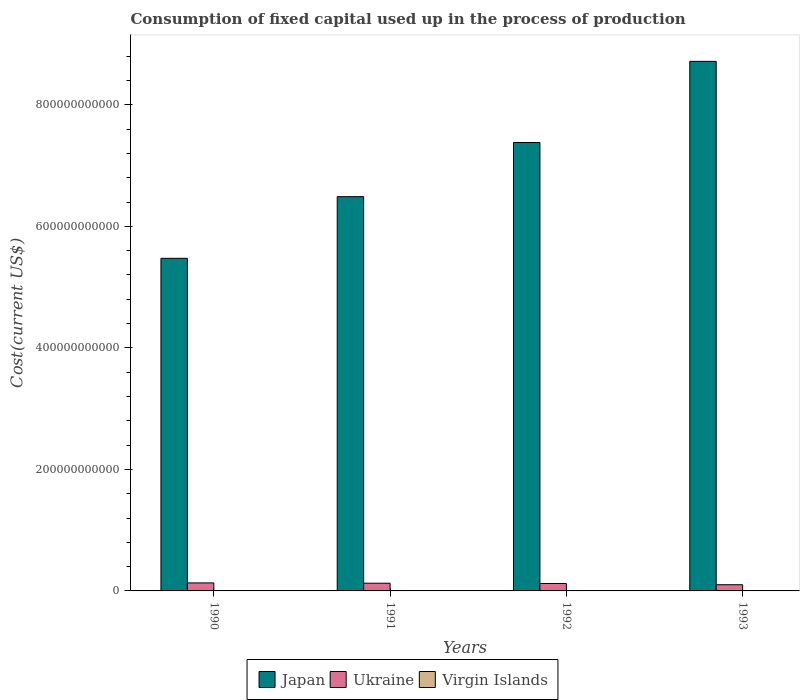How many different coloured bars are there?
Provide a succinct answer. 3. How many groups of bars are there?
Give a very brief answer. 4. Are the number of bars per tick equal to the number of legend labels?
Make the answer very short. Yes. How many bars are there on the 1st tick from the left?
Give a very brief answer. 3. What is the amount consumed in the process of production in Japan in 1992?
Provide a succinct answer. 7.38e+11. Across all years, what is the maximum amount consumed in the process of production in Japan?
Provide a succinct answer. 8.72e+11. Across all years, what is the minimum amount consumed in the process of production in Virgin Islands?
Make the answer very short. 2.21e+08. In which year was the amount consumed in the process of production in Virgin Islands maximum?
Your response must be concise. 1993. What is the total amount consumed in the process of production in Japan in the graph?
Make the answer very short. 2.81e+12. What is the difference between the amount consumed in the process of production in Ukraine in 1992 and that in 1993?
Your answer should be very brief. 2.01e+09. What is the difference between the amount consumed in the process of production in Ukraine in 1991 and the amount consumed in the process of production in Virgin Islands in 1990?
Give a very brief answer. 1.24e+1. What is the average amount consumed in the process of production in Ukraine per year?
Offer a very short reply. 1.21e+1. In the year 1991, what is the difference between the amount consumed in the process of production in Japan and amount consumed in the process of production in Ukraine?
Give a very brief answer. 6.36e+11. What is the ratio of the amount consumed in the process of production in Ukraine in 1990 to that in 1993?
Provide a short and direct response. 1.29. Is the amount consumed in the process of production in Ukraine in 1992 less than that in 1993?
Make the answer very short. No. What is the difference between the highest and the second highest amount consumed in the process of production in Virgin Islands?
Your answer should be very brief. 3.59e+07. What is the difference between the highest and the lowest amount consumed in the process of production in Ukraine?
Your answer should be compact. 2.97e+09. In how many years, is the amount consumed in the process of production in Japan greater than the average amount consumed in the process of production in Japan taken over all years?
Give a very brief answer. 2. Is the sum of the amount consumed in the process of production in Virgin Islands in 1990 and 1992 greater than the maximum amount consumed in the process of production in Ukraine across all years?
Make the answer very short. No. What does the 3rd bar from the left in 1992 represents?
Keep it short and to the point. Virgin Islands. What does the 2nd bar from the right in 1992 represents?
Keep it short and to the point. Ukraine. Are all the bars in the graph horizontal?
Your answer should be compact. No. How many years are there in the graph?
Make the answer very short. 4. What is the difference between two consecutive major ticks on the Y-axis?
Offer a very short reply. 2.00e+11. Are the values on the major ticks of Y-axis written in scientific E-notation?
Your answer should be compact. No. Where does the legend appear in the graph?
Provide a short and direct response. Bottom center. How many legend labels are there?
Your response must be concise. 3. How are the legend labels stacked?
Ensure brevity in your answer.  Horizontal. What is the title of the graph?
Your answer should be very brief. Consumption of fixed capital used up in the process of production. Does "Moldova" appear as one of the legend labels in the graph?
Provide a short and direct response. No. What is the label or title of the X-axis?
Ensure brevity in your answer.  Years. What is the label or title of the Y-axis?
Your answer should be compact. Cost(current US$). What is the Cost(current US$) of Japan in 1990?
Offer a terse response. 5.47e+11. What is the Cost(current US$) in Ukraine in 1990?
Make the answer very short. 1.32e+1. What is the Cost(current US$) of Virgin Islands in 1990?
Give a very brief answer. 2.21e+08. What is the Cost(current US$) in Japan in 1991?
Your answer should be compact. 6.49e+11. What is the Cost(current US$) of Ukraine in 1991?
Provide a short and direct response. 1.27e+1. What is the Cost(current US$) in Virgin Islands in 1991?
Offer a very short reply. 2.37e+08. What is the Cost(current US$) of Japan in 1992?
Provide a succinct answer. 7.38e+11. What is the Cost(current US$) of Ukraine in 1992?
Ensure brevity in your answer.  1.22e+1. What is the Cost(current US$) of Virgin Islands in 1992?
Your answer should be very brief. 2.53e+08. What is the Cost(current US$) in Japan in 1993?
Ensure brevity in your answer.  8.72e+11. What is the Cost(current US$) in Ukraine in 1993?
Offer a very short reply. 1.02e+1. What is the Cost(current US$) of Virgin Islands in 1993?
Your answer should be compact. 2.89e+08. Across all years, what is the maximum Cost(current US$) of Japan?
Your answer should be very brief. 8.72e+11. Across all years, what is the maximum Cost(current US$) of Ukraine?
Give a very brief answer. 1.32e+1. Across all years, what is the maximum Cost(current US$) in Virgin Islands?
Give a very brief answer. 2.89e+08. Across all years, what is the minimum Cost(current US$) of Japan?
Ensure brevity in your answer.  5.47e+11. Across all years, what is the minimum Cost(current US$) of Ukraine?
Offer a terse response. 1.02e+1. Across all years, what is the minimum Cost(current US$) of Virgin Islands?
Provide a succinct answer. 2.21e+08. What is the total Cost(current US$) in Japan in the graph?
Ensure brevity in your answer.  2.81e+12. What is the total Cost(current US$) in Ukraine in the graph?
Your response must be concise. 4.82e+1. What is the total Cost(current US$) of Virgin Islands in the graph?
Keep it short and to the point. 1.00e+09. What is the difference between the Cost(current US$) in Japan in 1990 and that in 1991?
Provide a succinct answer. -1.01e+11. What is the difference between the Cost(current US$) in Ukraine in 1990 and that in 1991?
Offer a terse response. 5.13e+08. What is the difference between the Cost(current US$) in Virgin Islands in 1990 and that in 1991?
Your answer should be compact. -1.67e+07. What is the difference between the Cost(current US$) of Japan in 1990 and that in 1992?
Give a very brief answer. -1.91e+11. What is the difference between the Cost(current US$) of Ukraine in 1990 and that in 1992?
Your response must be concise. 9.63e+08. What is the difference between the Cost(current US$) in Virgin Islands in 1990 and that in 1992?
Your answer should be compact. -3.25e+07. What is the difference between the Cost(current US$) in Japan in 1990 and that in 1993?
Your answer should be compact. -3.24e+11. What is the difference between the Cost(current US$) of Ukraine in 1990 and that in 1993?
Offer a very short reply. 2.97e+09. What is the difference between the Cost(current US$) in Virgin Islands in 1990 and that in 1993?
Make the answer very short. -6.84e+07. What is the difference between the Cost(current US$) of Japan in 1991 and that in 1992?
Your response must be concise. -8.91e+1. What is the difference between the Cost(current US$) of Ukraine in 1991 and that in 1992?
Your answer should be very brief. 4.50e+08. What is the difference between the Cost(current US$) in Virgin Islands in 1991 and that in 1992?
Ensure brevity in your answer.  -1.58e+07. What is the difference between the Cost(current US$) of Japan in 1991 and that in 1993?
Provide a short and direct response. -2.23e+11. What is the difference between the Cost(current US$) in Ukraine in 1991 and that in 1993?
Your answer should be compact. 2.46e+09. What is the difference between the Cost(current US$) of Virgin Islands in 1991 and that in 1993?
Offer a very short reply. -5.16e+07. What is the difference between the Cost(current US$) in Japan in 1992 and that in 1993?
Your answer should be very brief. -1.34e+11. What is the difference between the Cost(current US$) in Ukraine in 1992 and that in 1993?
Make the answer very short. 2.01e+09. What is the difference between the Cost(current US$) of Virgin Islands in 1992 and that in 1993?
Offer a very short reply. -3.59e+07. What is the difference between the Cost(current US$) in Japan in 1990 and the Cost(current US$) in Ukraine in 1991?
Offer a terse response. 5.35e+11. What is the difference between the Cost(current US$) in Japan in 1990 and the Cost(current US$) in Virgin Islands in 1991?
Your response must be concise. 5.47e+11. What is the difference between the Cost(current US$) of Ukraine in 1990 and the Cost(current US$) of Virgin Islands in 1991?
Keep it short and to the point. 1.29e+1. What is the difference between the Cost(current US$) of Japan in 1990 and the Cost(current US$) of Ukraine in 1992?
Offer a very short reply. 5.35e+11. What is the difference between the Cost(current US$) in Japan in 1990 and the Cost(current US$) in Virgin Islands in 1992?
Offer a terse response. 5.47e+11. What is the difference between the Cost(current US$) in Ukraine in 1990 and the Cost(current US$) in Virgin Islands in 1992?
Offer a very short reply. 1.29e+1. What is the difference between the Cost(current US$) of Japan in 1990 and the Cost(current US$) of Ukraine in 1993?
Your answer should be very brief. 5.37e+11. What is the difference between the Cost(current US$) of Japan in 1990 and the Cost(current US$) of Virgin Islands in 1993?
Ensure brevity in your answer.  5.47e+11. What is the difference between the Cost(current US$) of Ukraine in 1990 and the Cost(current US$) of Virgin Islands in 1993?
Offer a terse response. 1.29e+1. What is the difference between the Cost(current US$) in Japan in 1991 and the Cost(current US$) in Ukraine in 1992?
Provide a succinct answer. 6.37e+11. What is the difference between the Cost(current US$) in Japan in 1991 and the Cost(current US$) in Virgin Islands in 1992?
Provide a succinct answer. 6.49e+11. What is the difference between the Cost(current US$) of Ukraine in 1991 and the Cost(current US$) of Virgin Islands in 1992?
Your response must be concise. 1.24e+1. What is the difference between the Cost(current US$) in Japan in 1991 and the Cost(current US$) in Ukraine in 1993?
Your answer should be very brief. 6.39e+11. What is the difference between the Cost(current US$) of Japan in 1991 and the Cost(current US$) of Virgin Islands in 1993?
Your response must be concise. 6.49e+11. What is the difference between the Cost(current US$) in Ukraine in 1991 and the Cost(current US$) in Virgin Islands in 1993?
Your answer should be very brief. 1.24e+1. What is the difference between the Cost(current US$) of Japan in 1992 and the Cost(current US$) of Ukraine in 1993?
Make the answer very short. 7.28e+11. What is the difference between the Cost(current US$) in Japan in 1992 and the Cost(current US$) in Virgin Islands in 1993?
Give a very brief answer. 7.38e+11. What is the difference between the Cost(current US$) in Ukraine in 1992 and the Cost(current US$) in Virgin Islands in 1993?
Your response must be concise. 1.19e+1. What is the average Cost(current US$) of Japan per year?
Keep it short and to the point. 7.01e+11. What is the average Cost(current US$) in Ukraine per year?
Give a very brief answer. 1.21e+1. What is the average Cost(current US$) in Virgin Islands per year?
Your answer should be very brief. 2.50e+08. In the year 1990, what is the difference between the Cost(current US$) of Japan and Cost(current US$) of Ukraine?
Provide a short and direct response. 5.34e+11. In the year 1990, what is the difference between the Cost(current US$) of Japan and Cost(current US$) of Virgin Islands?
Offer a very short reply. 5.47e+11. In the year 1990, what is the difference between the Cost(current US$) in Ukraine and Cost(current US$) in Virgin Islands?
Your answer should be very brief. 1.30e+1. In the year 1991, what is the difference between the Cost(current US$) in Japan and Cost(current US$) in Ukraine?
Your answer should be very brief. 6.36e+11. In the year 1991, what is the difference between the Cost(current US$) in Japan and Cost(current US$) in Virgin Islands?
Offer a very short reply. 6.49e+11. In the year 1991, what is the difference between the Cost(current US$) in Ukraine and Cost(current US$) in Virgin Islands?
Your answer should be very brief. 1.24e+1. In the year 1992, what is the difference between the Cost(current US$) of Japan and Cost(current US$) of Ukraine?
Make the answer very short. 7.26e+11. In the year 1992, what is the difference between the Cost(current US$) of Japan and Cost(current US$) of Virgin Islands?
Offer a very short reply. 7.38e+11. In the year 1992, what is the difference between the Cost(current US$) of Ukraine and Cost(current US$) of Virgin Islands?
Your answer should be very brief. 1.20e+1. In the year 1993, what is the difference between the Cost(current US$) of Japan and Cost(current US$) of Ukraine?
Ensure brevity in your answer.  8.61e+11. In the year 1993, what is the difference between the Cost(current US$) of Japan and Cost(current US$) of Virgin Islands?
Your answer should be very brief. 8.71e+11. In the year 1993, what is the difference between the Cost(current US$) in Ukraine and Cost(current US$) in Virgin Islands?
Make the answer very short. 9.91e+09. What is the ratio of the Cost(current US$) in Japan in 1990 to that in 1991?
Give a very brief answer. 0.84. What is the ratio of the Cost(current US$) in Ukraine in 1990 to that in 1991?
Ensure brevity in your answer.  1.04. What is the ratio of the Cost(current US$) in Virgin Islands in 1990 to that in 1991?
Make the answer very short. 0.93. What is the ratio of the Cost(current US$) in Japan in 1990 to that in 1992?
Your answer should be compact. 0.74. What is the ratio of the Cost(current US$) of Ukraine in 1990 to that in 1992?
Ensure brevity in your answer.  1.08. What is the ratio of the Cost(current US$) in Virgin Islands in 1990 to that in 1992?
Provide a succinct answer. 0.87. What is the ratio of the Cost(current US$) in Japan in 1990 to that in 1993?
Ensure brevity in your answer.  0.63. What is the ratio of the Cost(current US$) in Ukraine in 1990 to that in 1993?
Ensure brevity in your answer.  1.29. What is the ratio of the Cost(current US$) of Virgin Islands in 1990 to that in 1993?
Offer a very short reply. 0.76. What is the ratio of the Cost(current US$) of Japan in 1991 to that in 1992?
Provide a short and direct response. 0.88. What is the ratio of the Cost(current US$) in Ukraine in 1991 to that in 1992?
Your answer should be very brief. 1.04. What is the ratio of the Cost(current US$) in Virgin Islands in 1991 to that in 1992?
Offer a very short reply. 0.94. What is the ratio of the Cost(current US$) of Japan in 1991 to that in 1993?
Your answer should be compact. 0.74. What is the ratio of the Cost(current US$) in Ukraine in 1991 to that in 1993?
Your answer should be compact. 1.24. What is the ratio of the Cost(current US$) in Virgin Islands in 1991 to that in 1993?
Ensure brevity in your answer.  0.82. What is the ratio of the Cost(current US$) of Japan in 1992 to that in 1993?
Provide a short and direct response. 0.85. What is the ratio of the Cost(current US$) in Ukraine in 1992 to that in 1993?
Your answer should be very brief. 1.2. What is the ratio of the Cost(current US$) of Virgin Islands in 1992 to that in 1993?
Make the answer very short. 0.88. What is the difference between the highest and the second highest Cost(current US$) of Japan?
Provide a short and direct response. 1.34e+11. What is the difference between the highest and the second highest Cost(current US$) of Ukraine?
Provide a short and direct response. 5.13e+08. What is the difference between the highest and the second highest Cost(current US$) of Virgin Islands?
Your answer should be compact. 3.59e+07. What is the difference between the highest and the lowest Cost(current US$) in Japan?
Give a very brief answer. 3.24e+11. What is the difference between the highest and the lowest Cost(current US$) in Ukraine?
Give a very brief answer. 2.97e+09. What is the difference between the highest and the lowest Cost(current US$) of Virgin Islands?
Ensure brevity in your answer.  6.84e+07. 